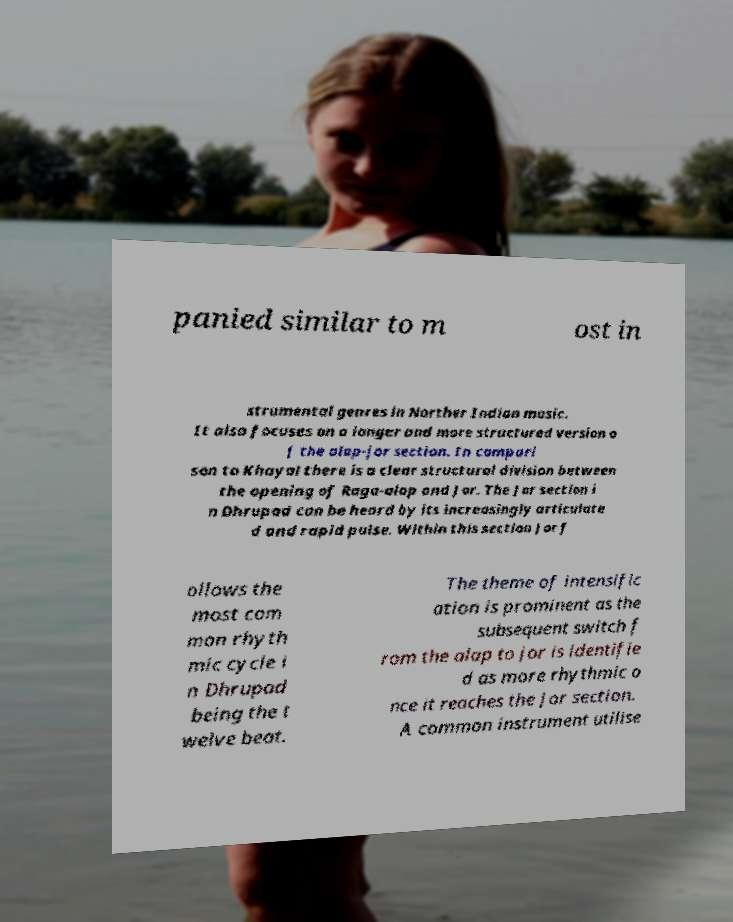There's text embedded in this image that I need extracted. Can you transcribe it verbatim? panied similar to m ost in strumental genres in Norther Indian music. It also focuses on a longer and more structured version o f the alap-jor section. In compari son to Khayal there is a clear structural division between the opening of Raga-alap and Jor. The Jor section i n Dhrupad can be heard by its increasingly articulate d and rapid pulse. Within this section Jor f ollows the most com mon rhyth mic cycle i n Dhrupad being the t welve beat. The theme of intensific ation is prominent as the subsequent switch f rom the alap to jor is identifie d as more rhythmic o nce it reaches the Jor section. A common instrument utilise 